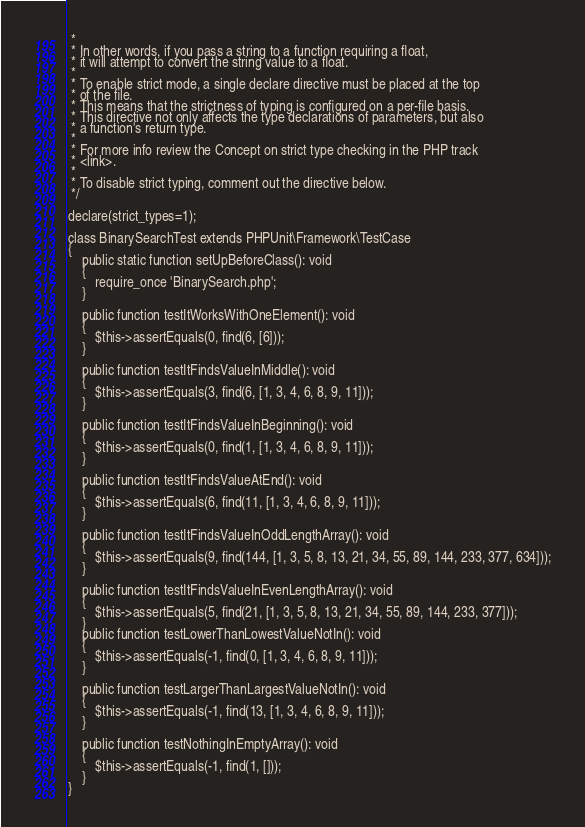<code> <loc_0><loc_0><loc_500><loc_500><_PHP_> *
 * In other words, if you pass a string to a function requiring a float,
 * it will attempt to convert the string value to a float.
 *
 * To enable strict mode, a single declare directive must be placed at the top
 * of the file.
 * This means that the strictness of typing is configured on a per-file basis.
 * This directive not only affects the type declarations of parameters, but also
 * a function's return type.
 *
 * For more info review the Concept on strict type checking in the PHP track
 * <link>.
 *
 * To disable strict typing, comment out the directive below.
 */

declare(strict_types=1);

class BinarySearchTest extends PHPUnit\Framework\TestCase
{
    public static function setUpBeforeClass(): void
    {
        require_once 'BinarySearch.php';
    }

    public function testItWorksWithOneElement(): void
    {
        $this->assertEquals(0, find(6, [6]));
    }

    public function testItFindsValueInMiddle(): void
    {
        $this->assertEquals(3, find(6, [1, 3, 4, 6, 8, 9, 11]));
    }

    public function testItFindsValueInBeginning(): void
    {
        $this->assertEquals(0, find(1, [1, 3, 4, 6, 8, 9, 11]));
    }

    public function testItFindsValueAtEnd(): void
    {
        $this->assertEquals(6, find(11, [1, 3, 4, 6, 8, 9, 11]));
    }

    public function testItFindsValueInOddLengthArray(): void
    {
        $this->assertEquals(9, find(144, [1, 3, 5, 8, 13, 21, 34, 55, 89, 144, 233, 377, 634]));
    }

    public function testItFindsValueInEvenLengthArray(): void
    {
        $this->assertEquals(5, find(21, [1, 3, 5, 8, 13, 21, 34, 55, 89, 144, 233, 377]));
    }
    public function testLowerThanLowestValueNotIn(): void
    {
        $this->assertEquals(-1, find(0, [1, 3, 4, 6, 8, 9, 11]));
    }

    public function testLargerThanLargestValueNotIn(): void
    {
        $this->assertEquals(-1, find(13, [1, 3, 4, 6, 8, 9, 11]));
    }

    public function testNothingInEmptyArray(): void
    {
        $this->assertEquals(-1, find(1, []));
    }
}
</code> 